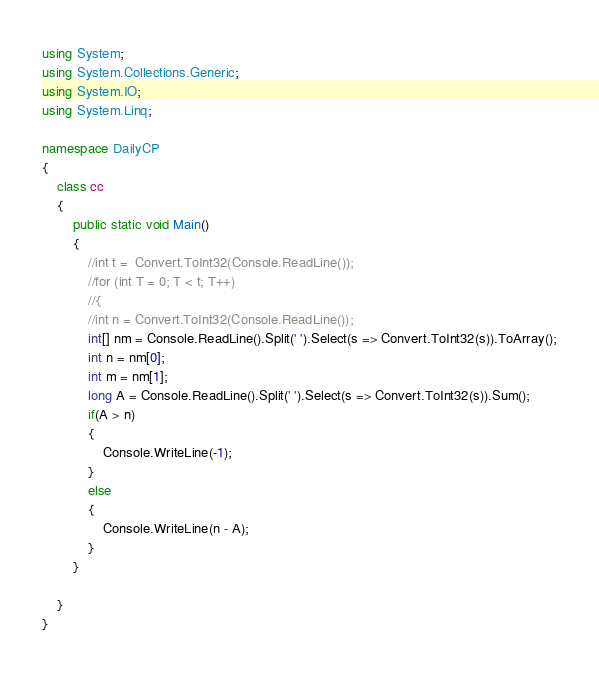Convert code to text. <code><loc_0><loc_0><loc_500><loc_500><_C#_>using System;
using System.Collections.Generic;
using System.IO;
using System.Linq;

namespace DailyCP
{
    class cc
    {
        public static void Main()
        {
            //int t =  Convert.ToInt32(Console.ReadLine());
            //for (int T = 0; T < t; T++)
            //{
            //int n = Convert.ToInt32(Console.ReadLine());
            int[] nm = Console.ReadLine().Split(' ').Select(s => Convert.ToInt32(s)).ToArray();
            int n = nm[0];
            int m = nm[1];
            long A = Console.ReadLine().Split(' ').Select(s => Convert.ToInt32(s)).Sum();
            if(A > n)
            {
                Console.WriteLine(-1);
            }
            else
            {
                Console.WriteLine(n - A);
            }            
        }
        
    }
}</code> 